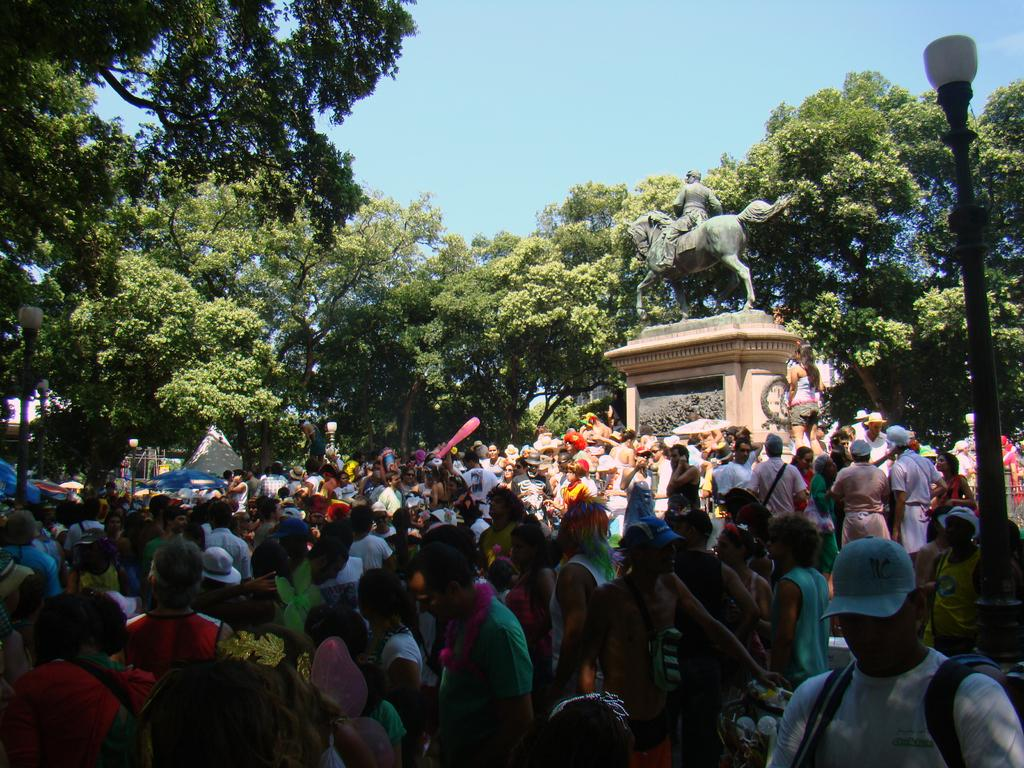What can be seen in the image? There are people, trees, a sculpture, and lights attached to poles in the image. Can you describe the people in the image? The facts provided do not give specific details about the people in the image. What type of object is the sculpture? The facts provided do not give specific details about the sculpture in the image. What is the purpose of the lights attached to poles? The purpose of the lights attached to poles is not specified in the provided facts. How does the sculpture grip the lights attached to poles in the image? The sculpture does not grip the lights attached to poles in the image; the sculpture and lights are separate objects. What type of self-awareness does the light in the image possess? The light in the image does not possess any self-awareness, as it is an inanimate object. 